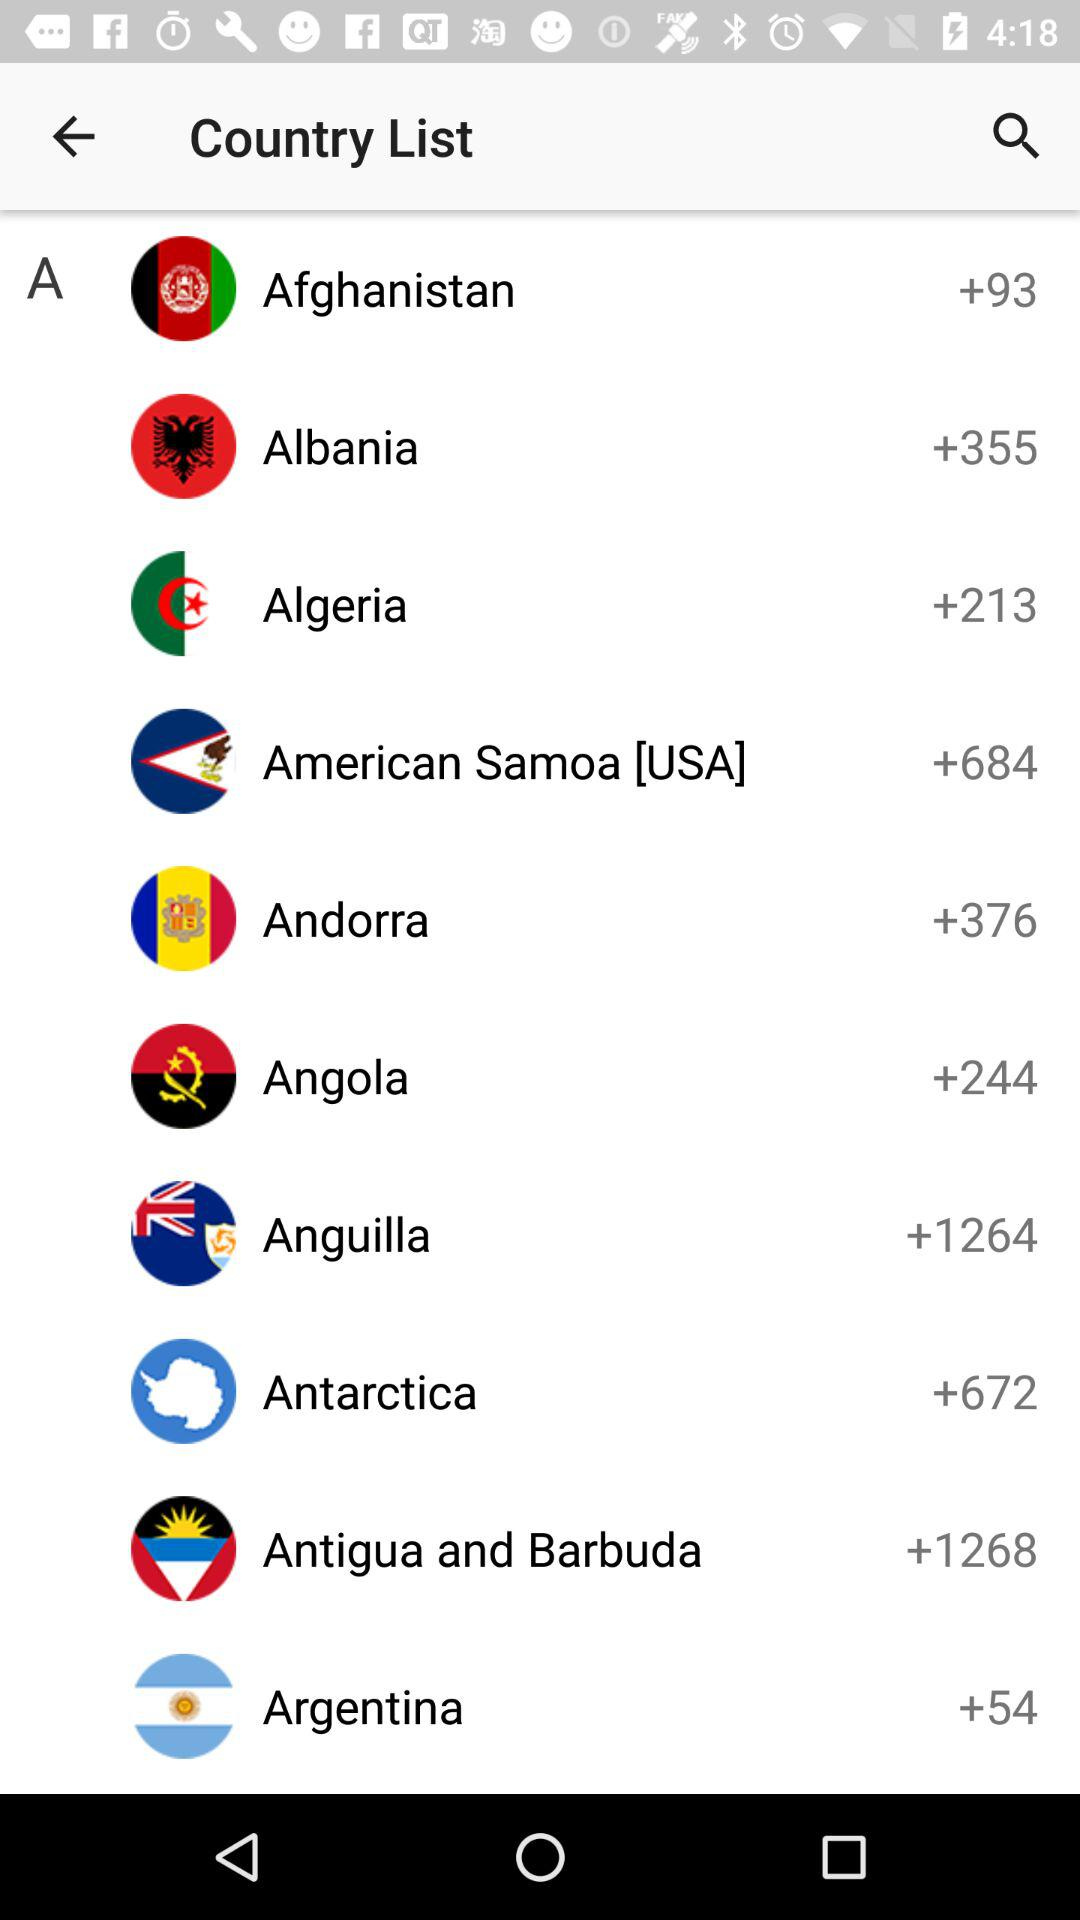What country has the code +684? The country that has a country code of +684 is American Samoa [USA]. 